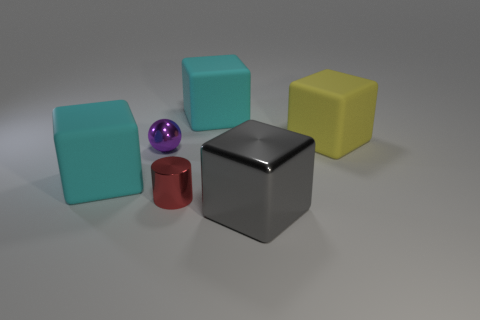Subtract all brown balls. How many cyan blocks are left? 2 Subtract all big gray metal cubes. How many cubes are left? 3 Subtract all yellow cubes. How many cubes are left? 3 Subtract all purple cubes. Subtract all purple spheres. How many cubes are left? 4 Add 1 big rubber cubes. How many objects exist? 7 Subtract all balls. How many objects are left? 5 Subtract all big yellow blocks. Subtract all large metal objects. How many objects are left? 4 Add 4 rubber objects. How many rubber objects are left? 7 Add 2 tiny purple balls. How many tiny purple balls exist? 3 Subtract 1 purple spheres. How many objects are left? 5 